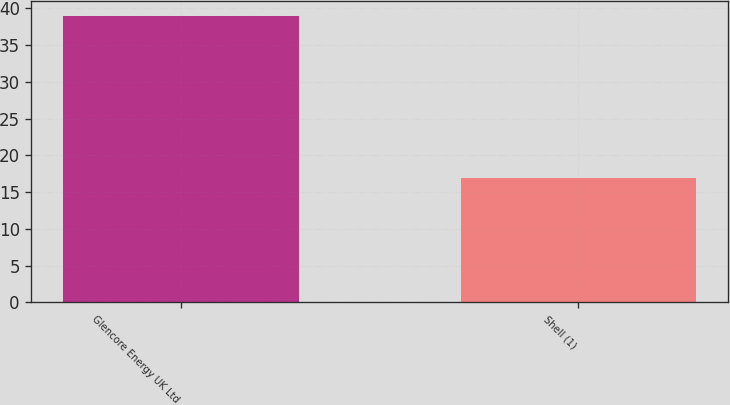Convert chart to OTSL. <chart><loc_0><loc_0><loc_500><loc_500><bar_chart><fcel>Glencore Energy UK Ltd<fcel>Shell (1)<nl><fcel>39<fcel>17<nl></chart> 